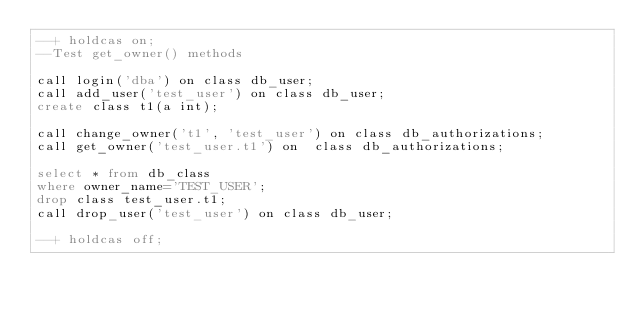Convert code to text. <code><loc_0><loc_0><loc_500><loc_500><_SQL_>--+ holdcas on;
--Test get_owner() methods 

call login('dba') on class db_user;
call add_user('test_user') on class db_user;
create class t1(a int);

call change_owner('t1', 'test_user') on class db_authorizations;
call get_owner('test_user.t1') on  class db_authorizations;

select * from db_class 
where owner_name='TEST_USER';
drop class test_user.t1;
call drop_user('test_user') on class db_user;

--+ holdcas off;
</code> 